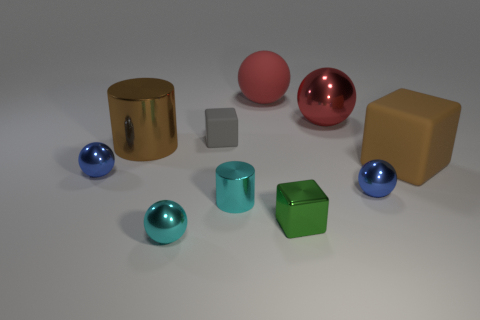Subtract all small blocks. How many blocks are left? 1 Subtract all cyan balls. How many balls are left? 4 Subtract 4 balls. How many balls are left? 1 Subtract all cylinders. How many objects are left? 8 Subtract all gray spheres. Subtract all red cubes. How many spheres are left? 5 Subtract all purple cubes. How many green cylinders are left? 0 Subtract all big metal objects. Subtract all shiny cylinders. How many objects are left? 6 Add 1 tiny blue metal spheres. How many tiny blue metal spheres are left? 3 Add 9 brown shiny objects. How many brown shiny objects exist? 10 Subtract 0 green balls. How many objects are left? 10 